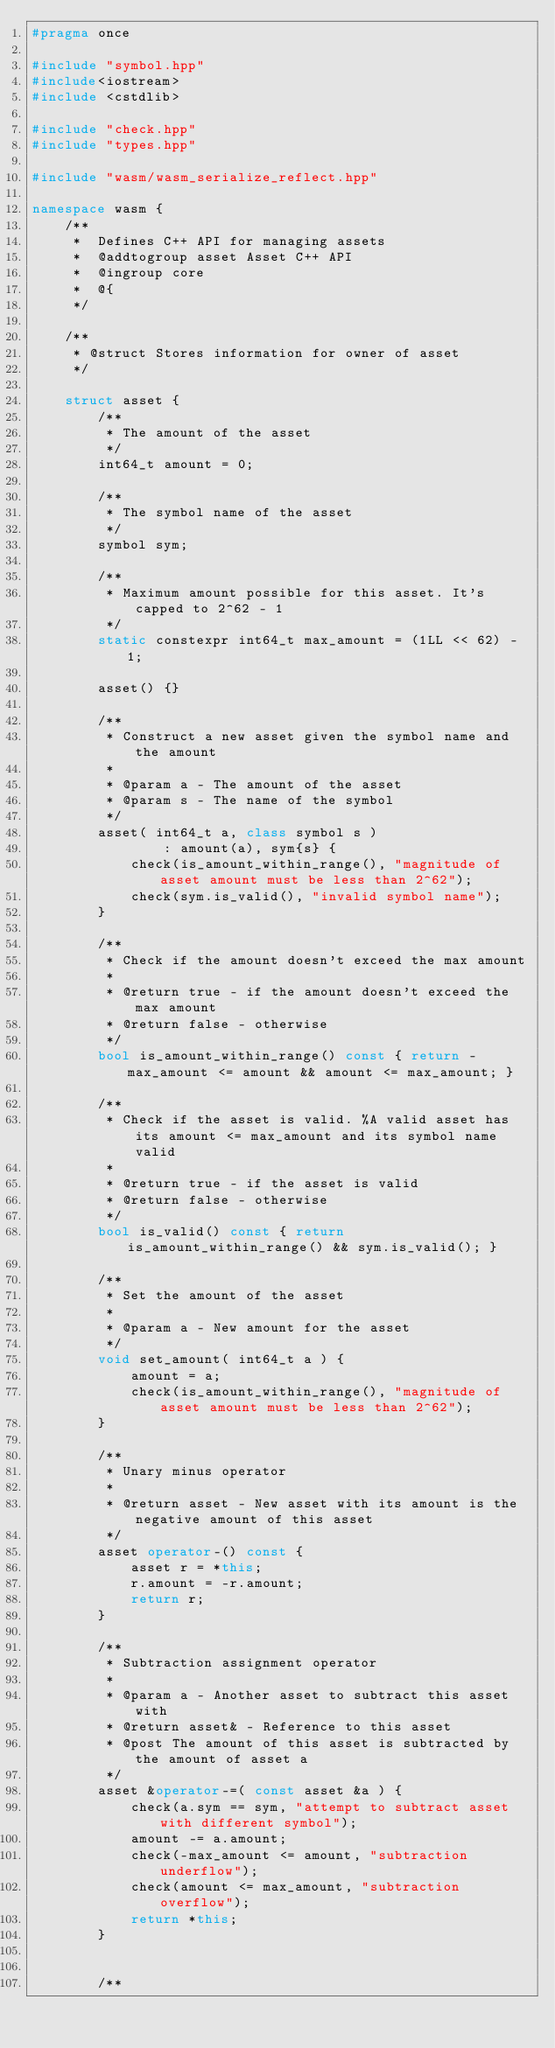Convert code to text. <code><loc_0><loc_0><loc_500><loc_500><_C++_>#pragma once

#include "symbol.hpp"
#include<iostream>
#include <cstdlib>

#include "check.hpp"
#include "types.hpp"

#include "wasm/wasm_serialize_reflect.hpp"

namespace wasm {
    /**
     *  Defines C++ API for managing assets
     *  @addtogroup asset Asset C++ API
     *  @ingroup core
     *  @{
     */

    /**
     * @struct Stores information for owner of asset
     */

    struct asset {
        /**
         * The amount of the asset
         */
        int64_t amount = 0;

        /**
         * The symbol name of the asset
         */
        symbol sym;

        /**
         * Maximum amount possible for this asset. It's capped to 2^62 - 1
         */
        static constexpr int64_t max_amount = (1LL << 62) - 1;

        asset() {}

        /**
         * Construct a new asset given the symbol name and the amount
         *
         * @param a - The amount of the asset
         * @param s - The name of the symbol
         */
        asset( int64_t a, class symbol s )
                : amount(a), sym{s} {
            check(is_amount_within_range(), "magnitude of asset amount must be less than 2^62");
            check(sym.is_valid(), "invalid symbol name");
        }

        /**
         * Check if the amount doesn't exceed the max amount
         *
         * @return true - if the amount doesn't exceed the max amount
         * @return false - otherwise
         */
        bool is_amount_within_range() const { return -max_amount <= amount && amount <= max_amount; }

        /**
         * Check if the asset is valid. %A valid asset has its amount <= max_amount and its symbol name valid
         *
         * @return true - if the asset is valid
         * @return false - otherwise
         */
        bool is_valid() const { return is_amount_within_range() && sym.is_valid(); }

        /**
         * Set the amount of the asset
         *
         * @param a - New amount for the asset
         */
        void set_amount( int64_t a ) {
            amount = a;
            check(is_amount_within_range(), "magnitude of asset amount must be less than 2^62");
        }

        /**
         * Unary minus operator
         *
         * @return asset - New asset with its amount is the negative amount of this asset
         */
        asset operator-() const {
            asset r = *this;
            r.amount = -r.amount;
            return r;
        }

        /**
         * Subtraction assignment operator
         *
         * @param a - Another asset to subtract this asset with
         * @return asset& - Reference to this asset
         * @post The amount of this asset is subtracted by the amount of asset a
         */
        asset &operator-=( const asset &a ) {
            check(a.sym == sym, "attempt to subtract asset with different symbol");
            amount -= a.amount;
            check(-max_amount <= amount, "subtraction underflow");
            check(amount <= max_amount, "subtraction overflow");
            return *this;
        }


        /**</code> 